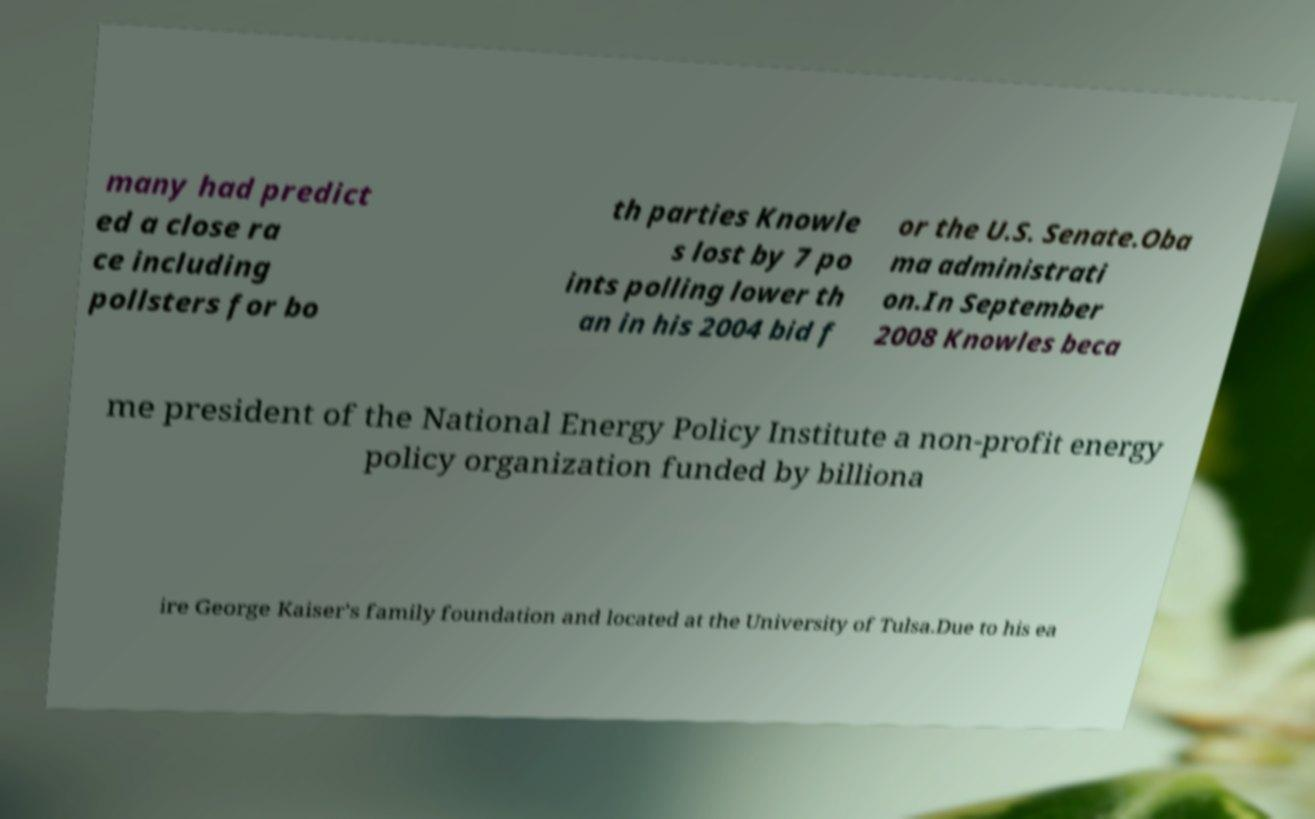For documentation purposes, I need the text within this image transcribed. Could you provide that? many had predict ed a close ra ce including pollsters for bo th parties Knowle s lost by 7 po ints polling lower th an in his 2004 bid f or the U.S. Senate.Oba ma administrati on.In September 2008 Knowles beca me president of the National Energy Policy Institute a non-profit energy policy organization funded by billiona ire George Kaiser's family foundation and located at the University of Tulsa.Due to his ea 